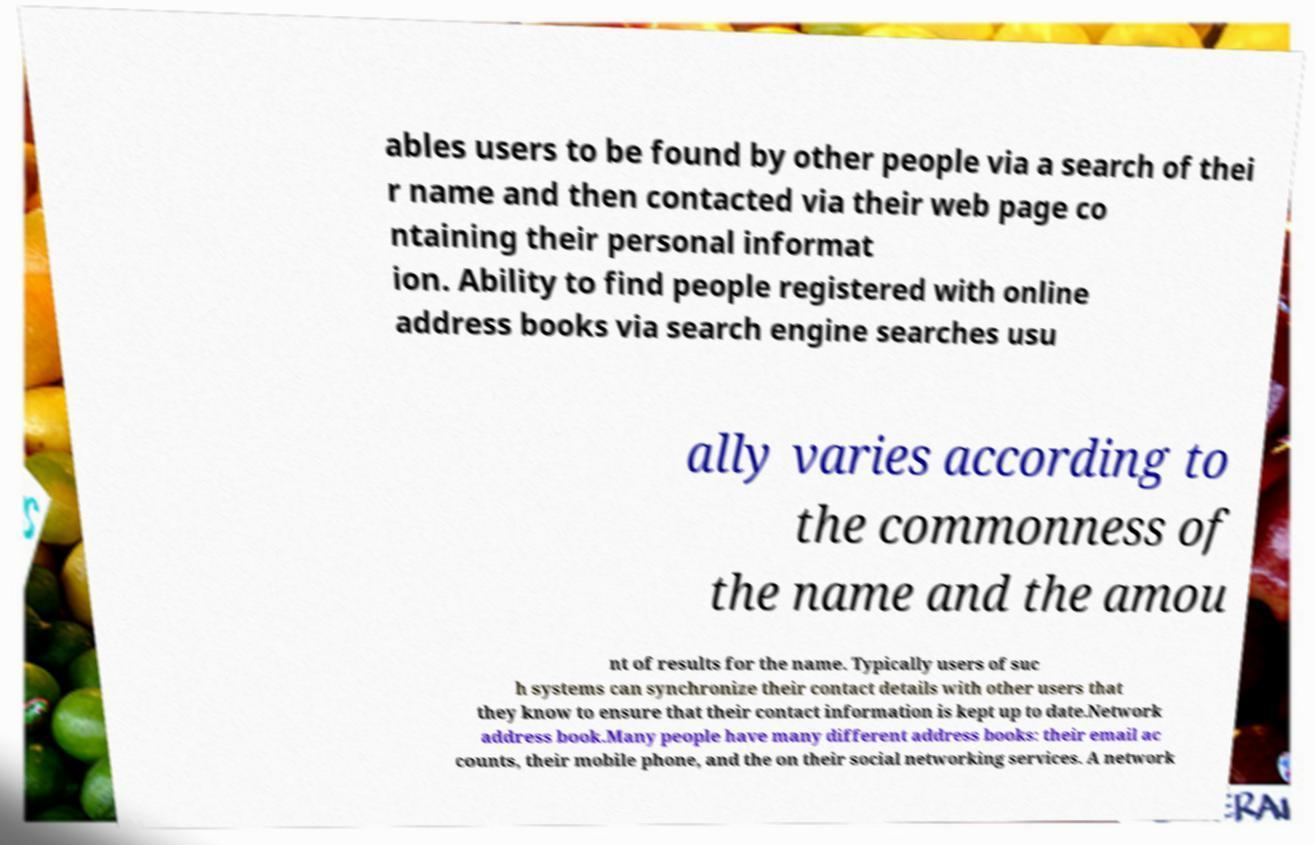What messages or text are displayed in this image? I need them in a readable, typed format. ables users to be found by other people via a search of thei r name and then contacted via their web page co ntaining their personal informat ion. Ability to find people registered with online address books via search engine searches usu ally varies according to the commonness of the name and the amou nt of results for the name. Typically users of suc h systems can synchronize their contact details with other users that they know to ensure that their contact information is kept up to date.Network address book.Many people have many different address books: their email ac counts, their mobile phone, and the on their social networking services. A network 